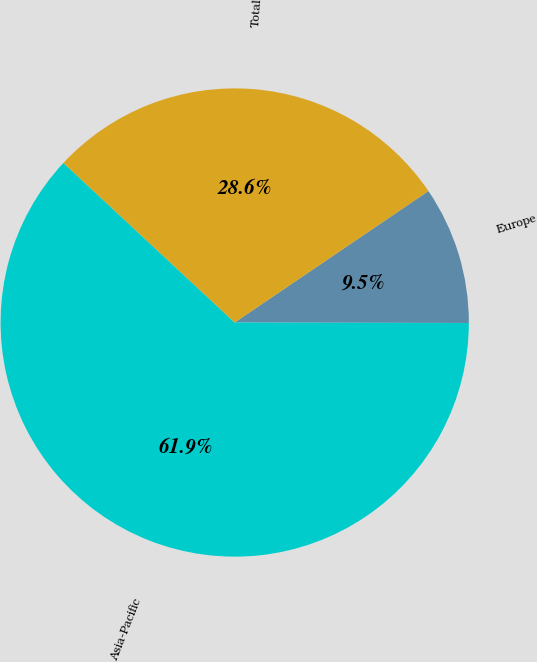<chart> <loc_0><loc_0><loc_500><loc_500><pie_chart><fcel>Europe<fcel>Asia-Pacific<fcel>Total<nl><fcel>9.52%<fcel>61.9%<fcel>28.57%<nl></chart> 